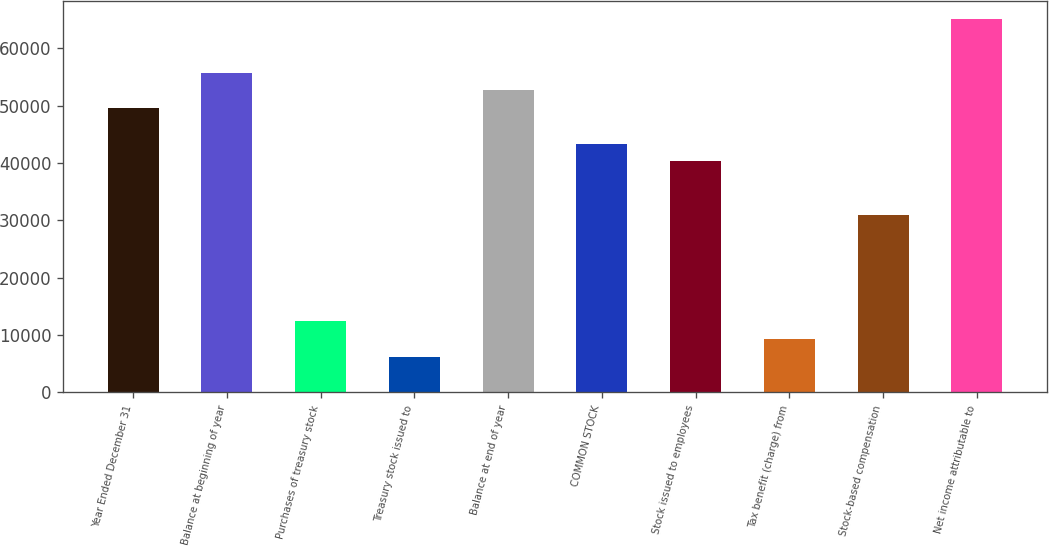Convert chart to OTSL. <chart><loc_0><loc_0><loc_500><loc_500><bar_chart><fcel>Year Ended December 31<fcel>Balance at beginning of year<fcel>Purchases of treasury stock<fcel>Treasury stock issued to<fcel>Balance at end of year<fcel>COMMON STOCK<fcel>Stock issued to employees<fcel>Tax benefit (charge) from<fcel>Stock-based compensation<fcel>Net income attributable to<nl><fcel>49604.2<fcel>55804.6<fcel>12401.8<fcel>6201.4<fcel>52704.4<fcel>43403.8<fcel>40303.6<fcel>9301.6<fcel>31003<fcel>65105.2<nl></chart> 